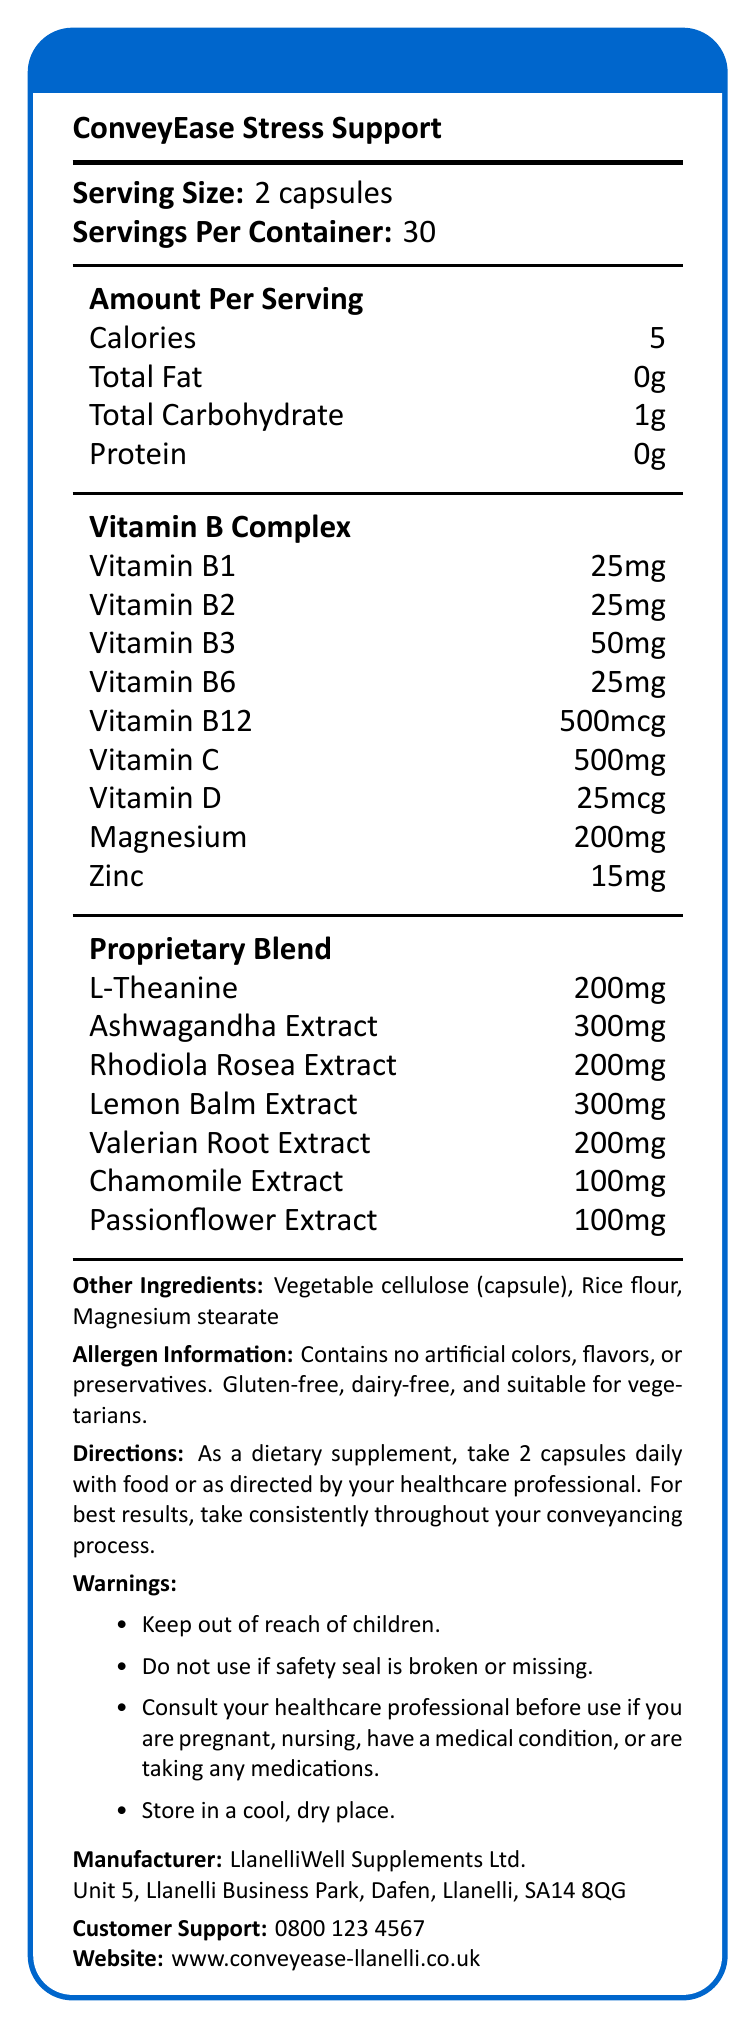what is the serving size of ConveyEase Stress Support? The document states that the serving size is 2 capsules.
Answer: 2 capsules what is the total carbohydrate content per serving? The document shows that the total carbohydrate content per serving is 1g.
Answer: 1g how many calories are there in a single serving? The Nutrition Facts indicate that a single serving of 2 capsules contains 5 calories.
Answer: 5 calories what are the other ingredients included in ConveyEase Stress Support? The document lists the other ingredients as Vegetable cellulose (capsule), Rice flour, and Magnesium stearate.
Answer: Vegetable cellulose (capsule), Rice flour, Magnesium stearate how much Vitamin C is in one serving of ConveyEase Stress Support? The label states that each serving contains 500mg of Vitamin C.
Answer: 500mg which of the following vitamins are included in ConveyEase Stress Support's Vitamin B Complex? A. Vitamin B1, B2, B3, and B5 B. Vitamin B1, B2, B6, and B12 C. Vitamin B1, B3, B5, and B12 D. Vitamin B2, B3, B6, and B12 The document lists the vitamins in the Vitamin B Complex as B1, B2, B3, B6, and B12.
Answer: B. Vitamin B1, B2, B6, and B12 which additional extracts are part of the proprietary blend in ConveyEase Stress Support? A. Lemon Balm and Rhodiola Rosea B. Ginseng and Lavender C. Peppermint and Echinacea D. Turmeric and Ginger The proprietary blend contains Lemon Balm Extract and Rhodiola Rosea Extract among other ingredients.
Answer: A. Lemon Balm and Rhodiola Rosea is ConveyEase Stress Support suitable for vegetarians? The allergen information section states that the product is suitable for vegetarians.
Answer: Yes summarize the main idea of the document. The document offers a comprehensive overview of a stress support supplement called ConveyEase Stress Support, highlighting its nutritional information, intended use, and additional product details to assist individuals during the conveyancing process.
Answer: ConveyEase Stress Support is a dietary supplement designed to help manage stress during the conveyancing process. It includes various vitamins, minerals, and herbal extracts aimed at reducing stress. The product is manufactured by LlanelliWell Supplements Ltd., and it is gluten-free, dairy-free, and suitable for vegetarians. The document provides information on serving size, ingredients, directions for use, allergen information, and warnings. what are the directions for taking ConveyEase Stress Support? The directions specify to take 2 capsules daily with food, or as directed by a healthcare professional, and for best results, to take consistently throughout the conveyancing process.
Answer: Take 2 capsules daily with food or as directed by your healthcare professional. what is the contact number for customer support? The document lists the customer support contact number as 0800 123 4567.
Answer: 0800 123 4567 where is regular use recommended for best results? The directions section recommends consistent use of the supplement throughout the conveyancing process.
Answer: Throughout your conveyancing process what is the manufacturer's address? The manufacturer's address is provided as Unit 5, Llanelli Business Park, Dafen, Llanelli, SA14 8QG.
Answer: Unit 5, Llanelli Business Park, Dafen, Llanelli, SA14 8QG which vitamin has the highest amount per serving in mcg? The document shows that Vitamin B12 has the highest amount per serving, listed as 500mcg.
Answer: Vitamin B12 what is the source of L-Theanine listed in the proprietary blend? The document lists the amount of L-Theanine but does not specify its source.
Answer: Cannot be determined 